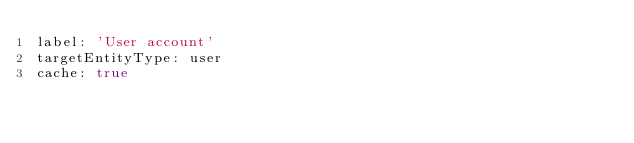<code> <loc_0><loc_0><loc_500><loc_500><_YAML_>label: 'User account'
targetEntityType: user
cache: true
</code> 